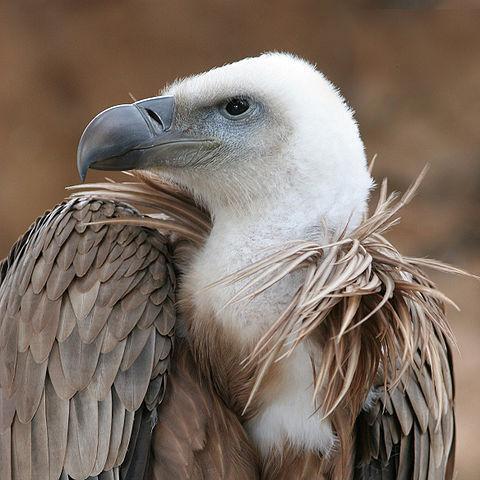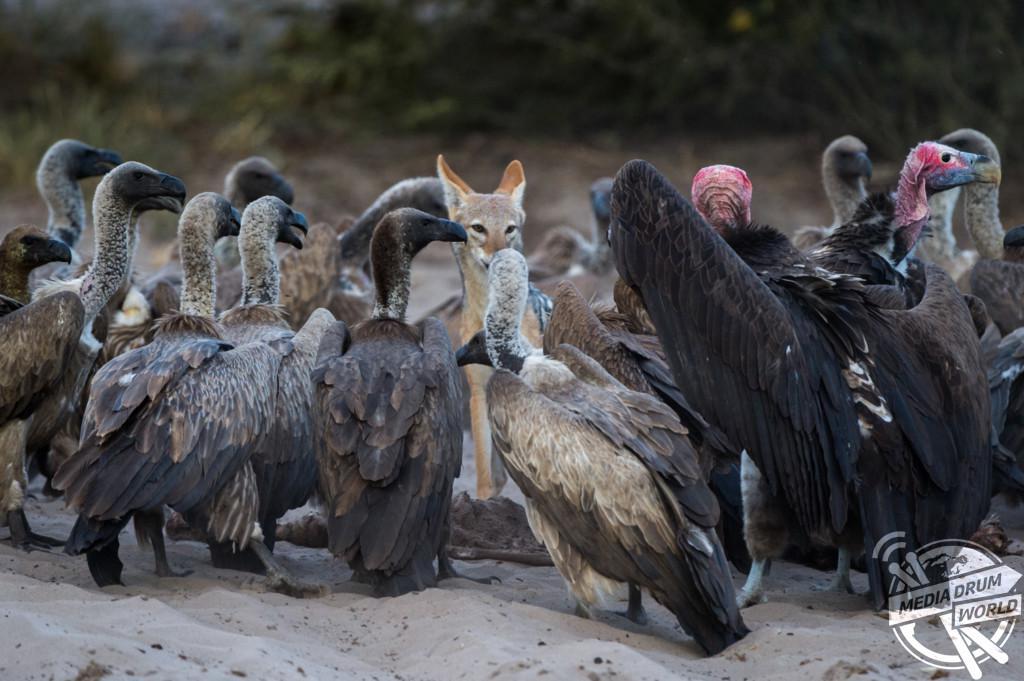The first image is the image on the left, the second image is the image on the right. Examine the images to the left and right. Is the description "There is exactly one brown dog in the image on the left." accurate? Answer yes or no. No. 